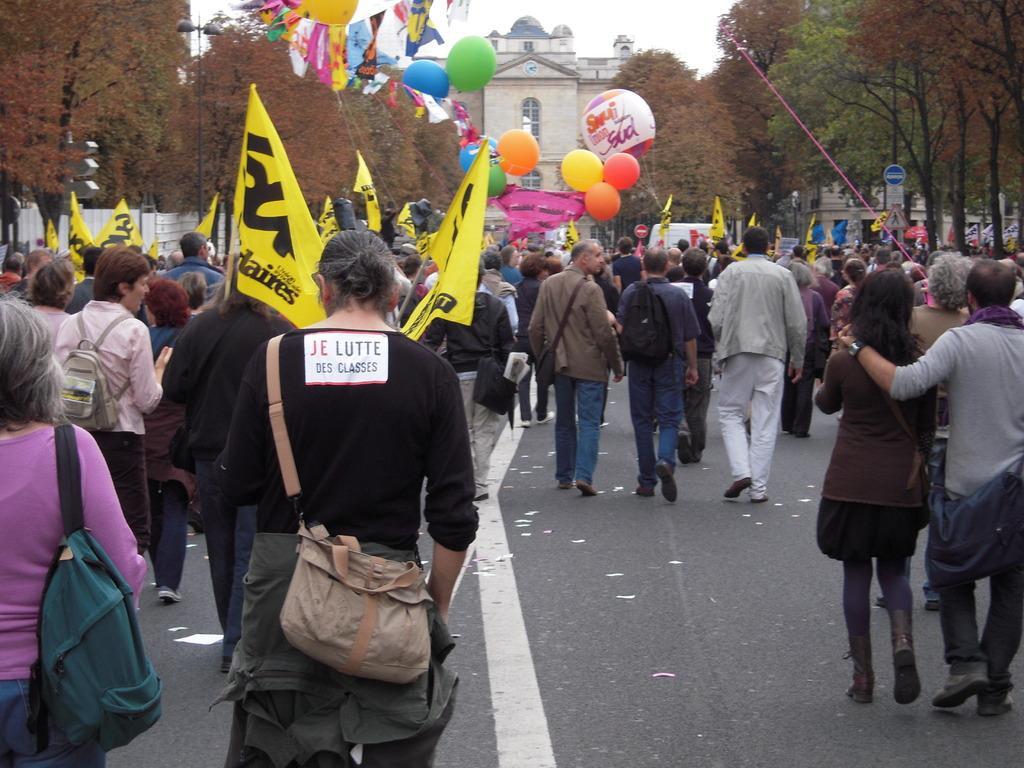Could you give a brief overview of what you see in this image? In this image we can see group people and holding some flags with some written text on it, we can see some balloons, near that we can see the trees, after that we can see a building with windows, at the top we can see the sky. 